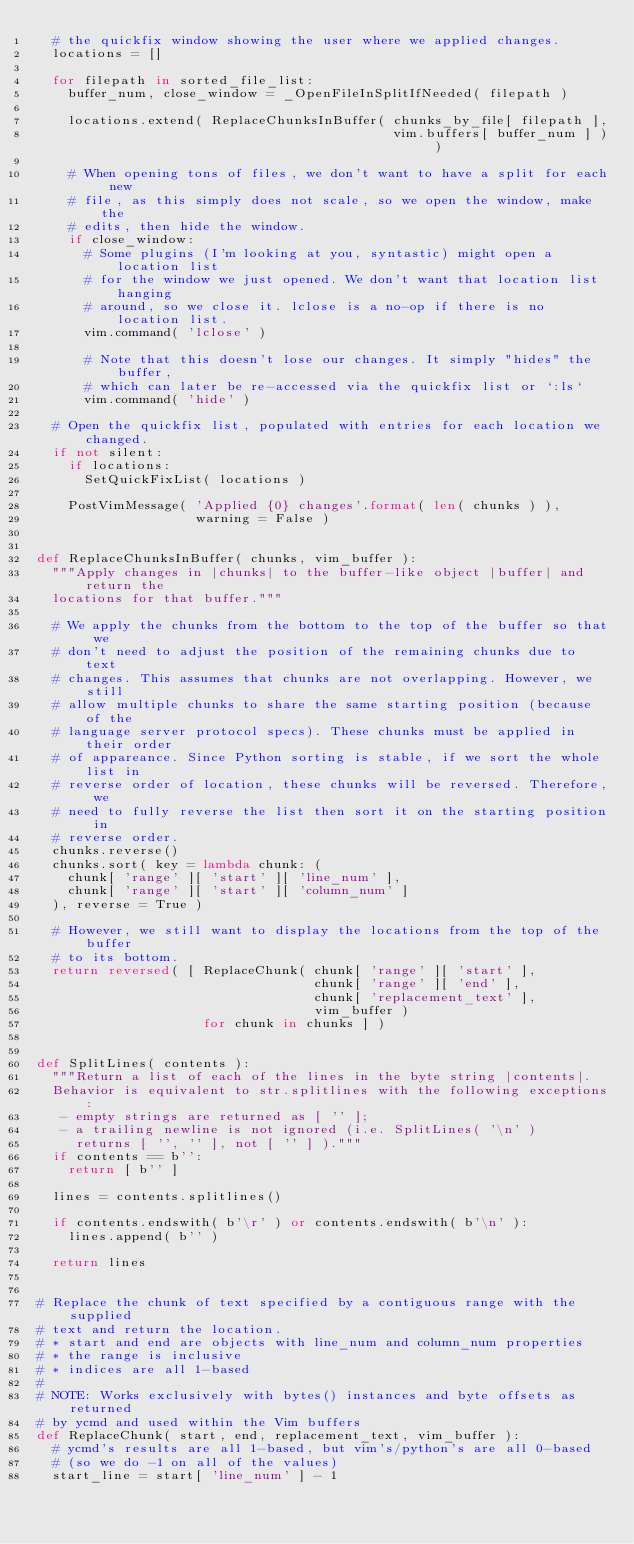Convert code to text. <code><loc_0><loc_0><loc_500><loc_500><_Python_>  # the quickfix window showing the user where we applied changes.
  locations = []

  for filepath in sorted_file_list:
    buffer_num, close_window = _OpenFileInSplitIfNeeded( filepath )

    locations.extend( ReplaceChunksInBuffer( chunks_by_file[ filepath ],
                                             vim.buffers[ buffer_num ] ) )

    # When opening tons of files, we don't want to have a split for each new
    # file, as this simply does not scale, so we open the window, make the
    # edits, then hide the window.
    if close_window:
      # Some plugins (I'm looking at you, syntastic) might open a location list
      # for the window we just opened. We don't want that location list hanging
      # around, so we close it. lclose is a no-op if there is no location list.
      vim.command( 'lclose' )

      # Note that this doesn't lose our changes. It simply "hides" the buffer,
      # which can later be re-accessed via the quickfix list or `:ls`
      vim.command( 'hide' )

  # Open the quickfix list, populated with entries for each location we changed.
  if not silent:
    if locations:
      SetQuickFixList( locations )

    PostVimMessage( 'Applied {0} changes'.format( len( chunks ) ),
                    warning = False )


def ReplaceChunksInBuffer( chunks, vim_buffer ):
  """Apply changes in |chunks| to the buffer-like object |buffer| and return the
  locations for that buffer."""

  # We apply the chunks from the bottom to the top of the buffer so that we
  # don't need to adjust the position of the remaining chunks due to text
  # changes. This assumes that chunks are not overlapping. However, we still
  # allow multiple chunks to share the same starting position (because of the
  # language server protocol specs). These chunks must be applied in their order
  # of appareance. Since Python sorting is stable, if we sort the whole list in
  # reverse order of location, these chunks will be reversed. Therefore, we
  # need to fully reverse the list then sort it on the starting position in
  # reverse order.
  chunks.reverse()
  chunks.sort( key = lambda chunk: (
    chunk[ 'range' ][ 'start' ][ 'line_num' ],
    chunk[ 'range' ][ 'start' ][ 'column_num' ]
  ), reverse = True )

  # However, we still want to display the locations from the top of the buffer
  # to its bottom.
  return reversed( [ ReplaceChunk( chunk[ 'range' ][ 'start' ],
                                   chunk[ 'range' ][ 'end' ],
                                   chunk[ 'replacement_text' ],
                                   vim_buffer )
                     for chunk in chunks ] )


def SplitLines( contents ):
  """Return a list of each of the lines in the byte string |contents|.
  Behavior is equivalent to str.splitlines with the following exceptions:
   - empty strings are returned as [ '' ];
   - a trailing newline is not ignored (i.e. SplitLines( '\n' )
     returns [ '', '' ], not [ '' ] )."""
  if contents == b'':
    return [ b'' ]

  lines = contents.splitlines()

  if contents.endswith( b'\r' ) or contents.endswith( b'\n' ):
    lines.append( b'' )

  return lines


# Replace the chunk of text specified by a contiguous range with the supplied
# text and return the location.
# * start and end are objects with line_num and column_num properties
# * the range is inclusive
# * indices are all 1-based
#
# NOTE: Works exclusively with bytes() instances and byte offsets as returned
# by ycmd and used within the Vim buffers
def ReplaceChunk( start, end, replacement_text, vim_buffer ):
  # ycmd's results are all 1-based, but vim's/python's are all 0-based
  # (so we do -1 on all of the values)
  start_line = start[ 'line_num' ] - 1</code> 